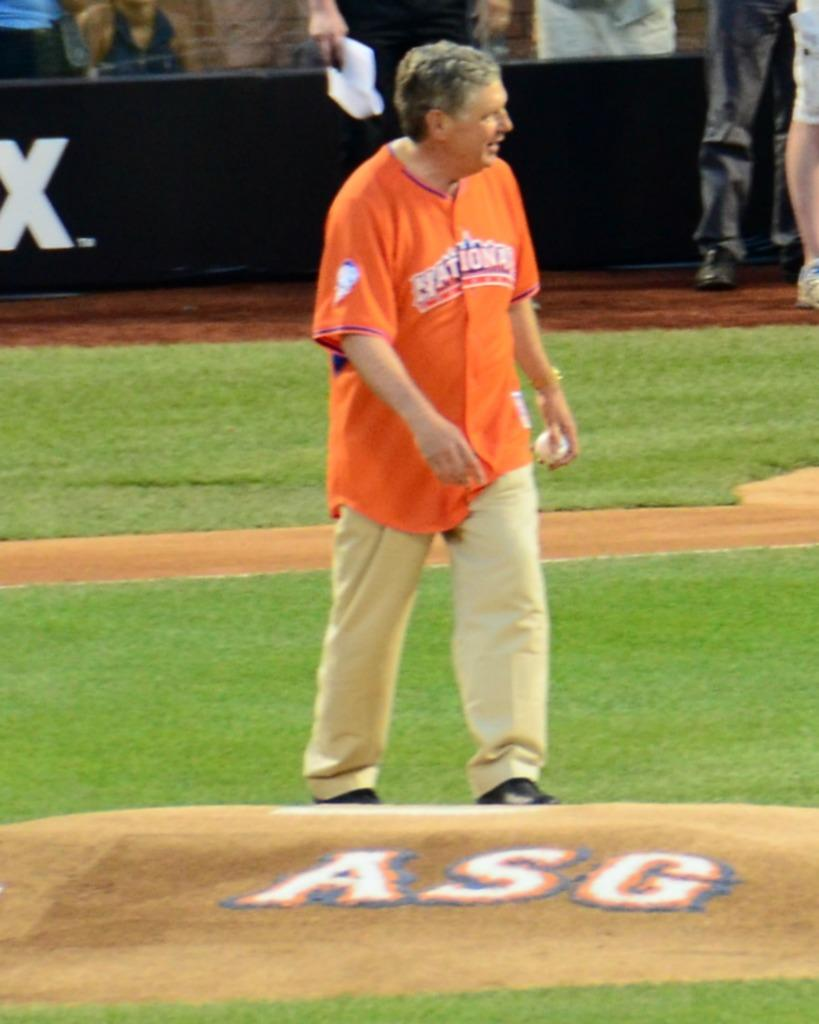<image>
Render a clear and concise summary of the photo. A man in an orange shirt walks towards the mound that ASG 